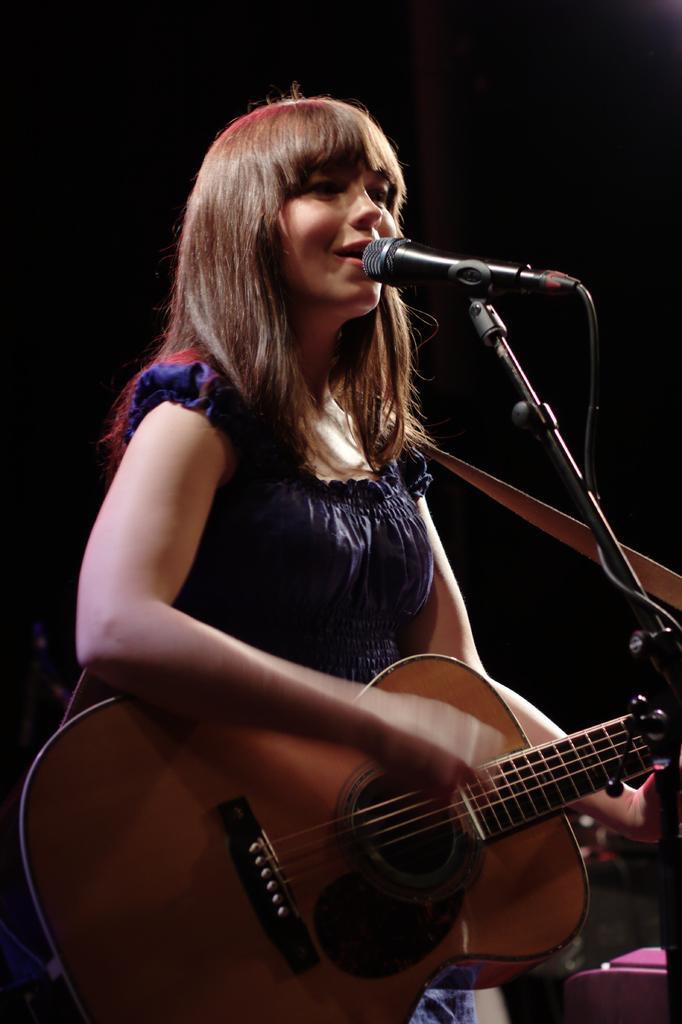How would you summarize this image in a sentence or two? She is standing. She is playing a guitar and she is singing a song. 